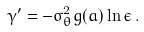Convert formula to latex. <formula><loc_0><loc_0><loc_500><loc_500>\gamma ^ { \prime } = - \sigma _ { \theta } ^ { 2 } g ( a ) \ln { \epsilon } \, .</formula> 